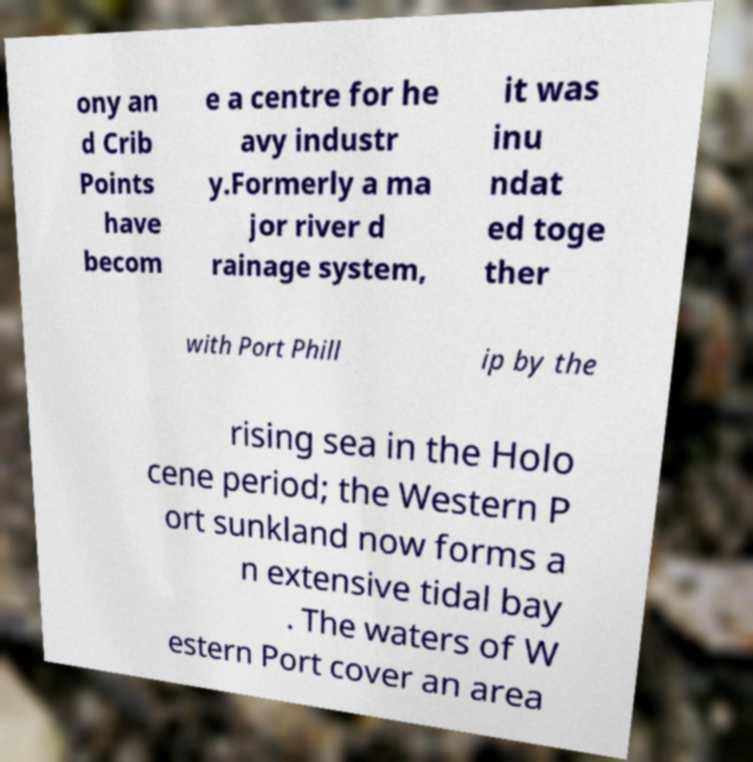Please identify and transcribe the text found in this image. ony an d Crib Points have becom e a centre for he avy industr y.Formerly a ma jor river d rainage system, it was inu ndat ed toge ther with Port Phill ip by the rising sea in the Holo cene period; the Western P ort sunkland now forms a n extensive tidal bay . The waters of W estern Port cover an area 